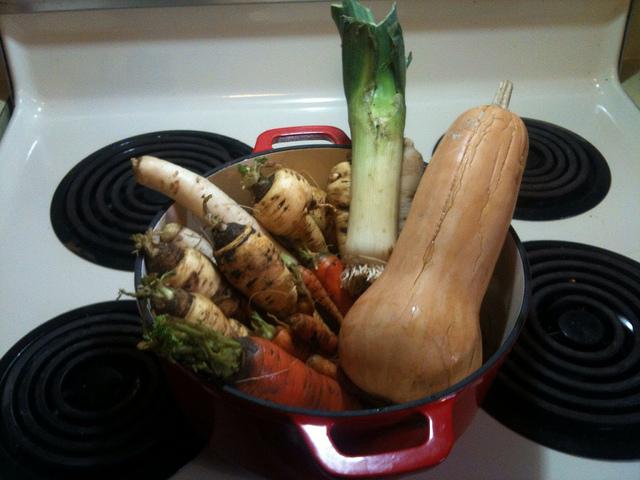What color is the pot?
Quick response, please. Red. Did these vegetables just come out of the garden?
Quick response, please. Yes. Is this stove electric or gas?
Write a very short answer. Electric. 